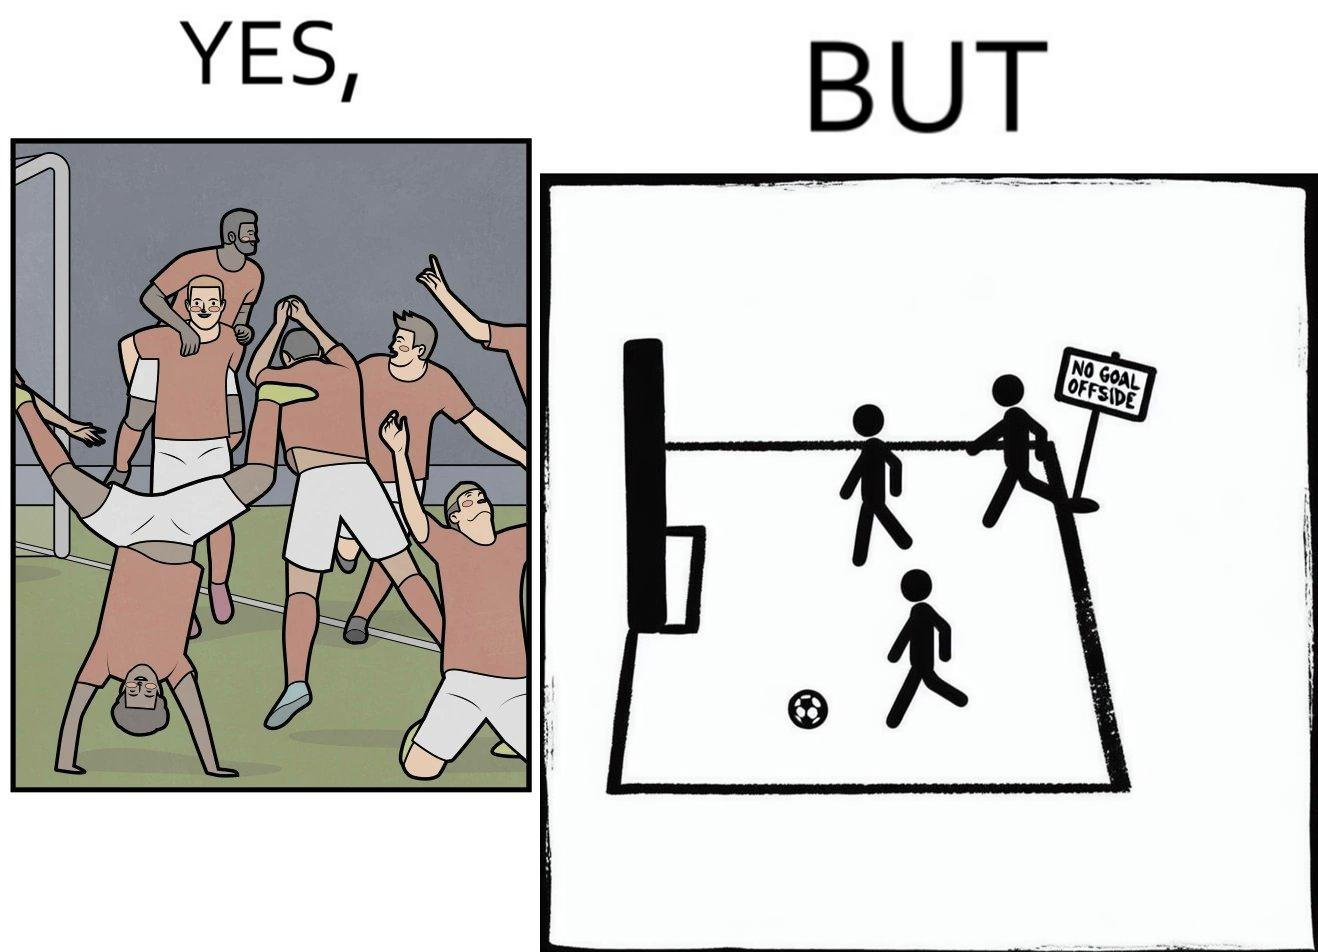Explain the humor or irony in this image. The image is ironical, as the team is celebrating as they think that they have scored a goal, but the sign on the screen says that it is an offside, and not a goal. This is a very common scenario in football matches. 